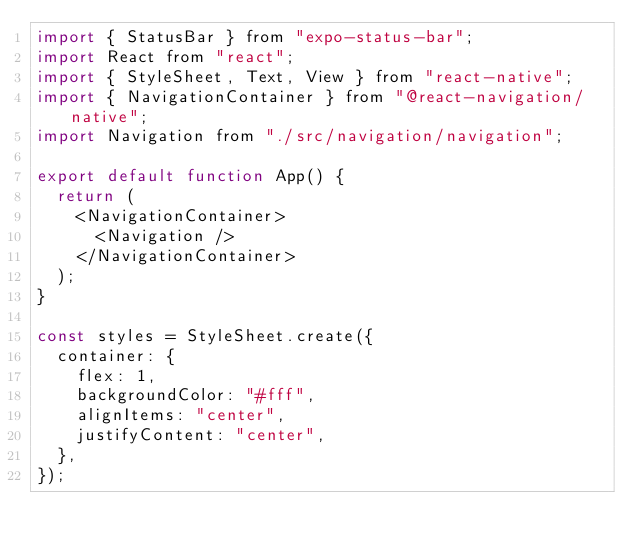Convert code to text. <code><loc_0><loc_0><loc_500><loc_500><_JavaScript_>import { StatusBar } from "expo-status-bar";
import React from "react";
import { StyleSheet, Text, View } from "react-native";
import { NavigationContainer } from "@react-navigation/native";
import Navigation from "./src/navigation/navigation";

export default function App() {
  return (
    <NavigationContainer>
      <Navigation />
    </NavigationContainer>
  );
}

const styles = StyleSheet.create({
  container: {
    flex: 1,
    backgroundColor: "#fff",
    alignItems: "center",
    justifyContent: "center",
  },
});
</code> 